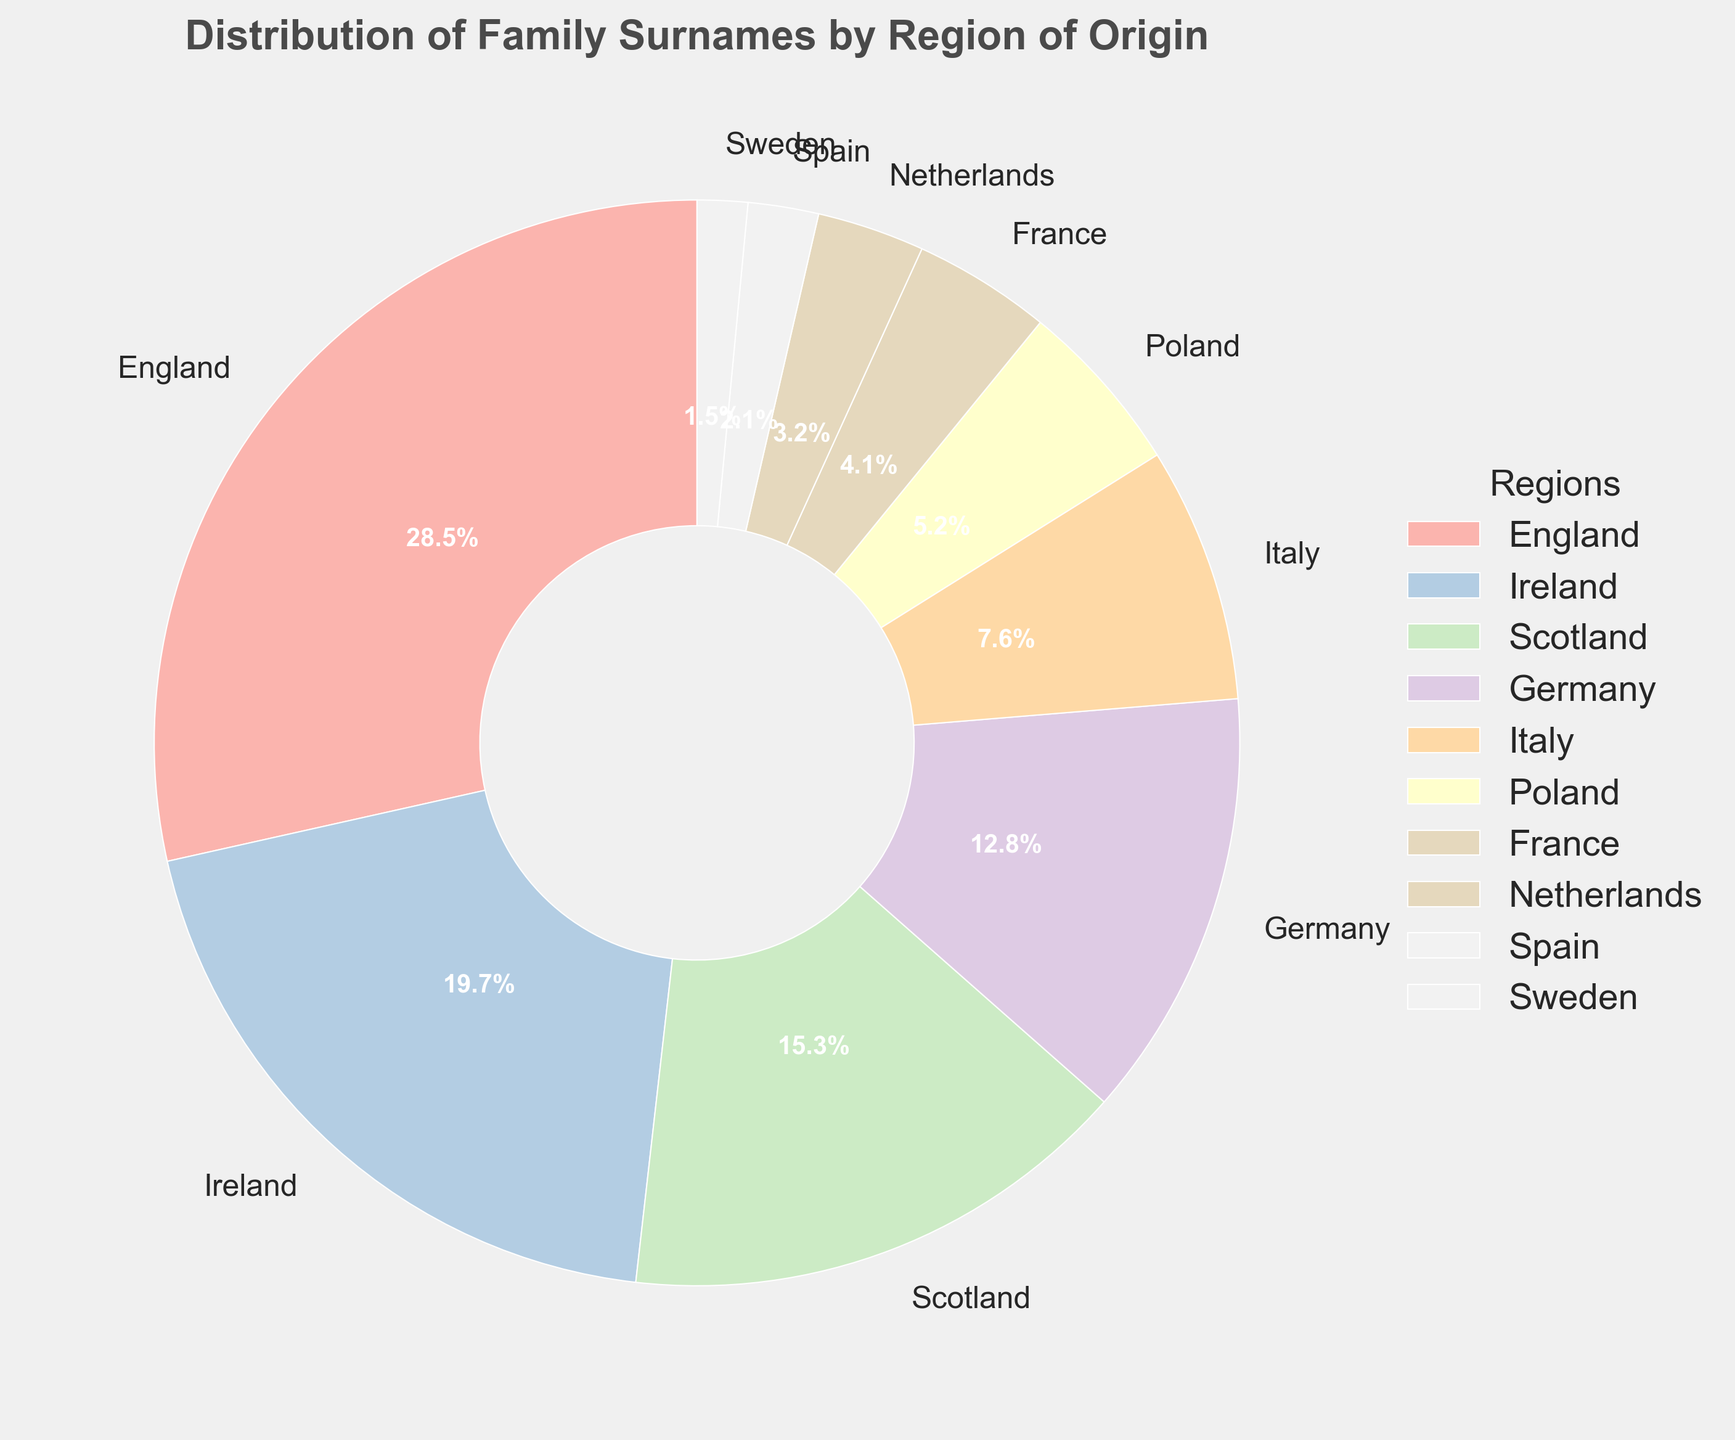What region has the highest percentage of family surnames? By looking at the largest section of the pie chart, we can see that England has the largest percentage of family surnames.
Answer: England Which two regions combined have a percentage greater than that of England? Summing the percentages of Ireland and Scotland (19.7 + 15.3) equals 35. This is greater than England's 28.5%.
Answer: Ireland and Scotland What is the difference in percentage between Germany and Poland? Subtract Poland's percentage (5.2) from Germany's percentage (12.8), resulting in a difference of 7.6%.
Answer: 7.6% How many regions have a percentage less than 5%? By examining the pie chart, we see that Poland, France, Netherlands, Spain, and Sweden all have percentages less than 5%. This totals to 5 regions.
Answer: 5 Which region has the smallest percentage of family surnames? By identifying the smallest section in the pie chart, we can see that Sweden has the smallest percentage.
Answer: Sweden Which regions combined have a total percentage of 50% or more? Reviewing the larger sections: England (28.5%) and Ireland (19.7%) sum up to 48.2%, still less than 50%. Adding Scotland's 15.3% to this results in 63.5%, which is more than 50%.
Answer: England, Ireland, and Scotland What is the sum of the percentages of family surnames from Italy, Poland, and France? Adding the percentages of Italy (7.6), Poland (5.2), and France (4.1) gives us a total of 16.9%.
Answer: 16.9% Between Ireland and Italy, which region has the higher percentage of family surnames and by how much? Comparing Ireland's percentage (19.7) with Italy's percentage (7.6), Ireland has the higher percentage. Subtracting Italy's percentage from Ireland's, the difference is 12.1%.
Answer: Ireland by 12.1% Which region has a percentage that is closest to the combined percentage of Sweden and Spain? Combining Sweden's percentage (1.5) with Spain's (2.1) equals 3.6%. The Netherlands with 3.2% is the closest to this combination.
Answer: Netherlands What is the average percentage of the family surnames of Germany, Italy, and France? Summing the percentages of Germany (12.8), Italy (7.6), and France (4.1) equals 24.5. Dividing this by 3, the average is approximately 8.17%.
Answer: 8.17% 